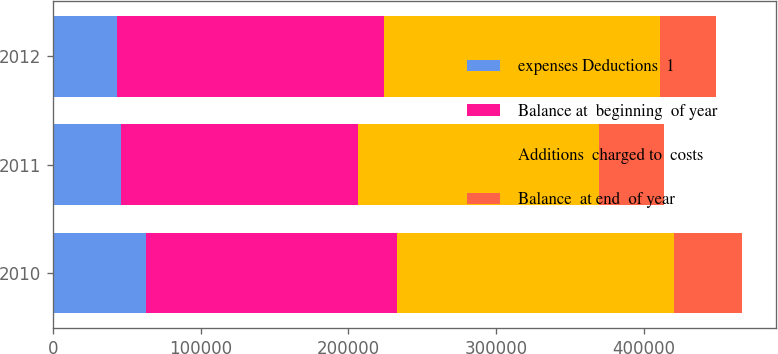Convert chart to OTSL. <chart><loc_0><loc_0><loc_500><loc_500><stacked_bar_chart><ecel><fcel>2010<fcel>2011<fcel>2012<nl><fcel>expenses Deductions  1<fcel>62809<fcel>45755<fcel>43705<nl><fcel>Balance at  beginning  of year<fcel>170274<fcel>161073<fcel>180616<nl><fcel>Additions  charged to  costs<fcel>187328<fcel>163123<fcel>186448<nl><fcel>Balance  at end  of year<fcel>45755<fcel>43705<fcel>37873<nl></chart> 